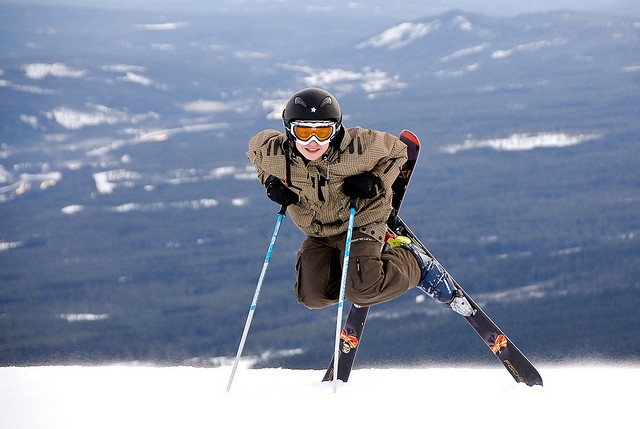Describe the objects in this image and their specific colors. I can see people in darkgray, black, and gray tones and skis in darkgray, black, gray, and lightgray tones in this image. 